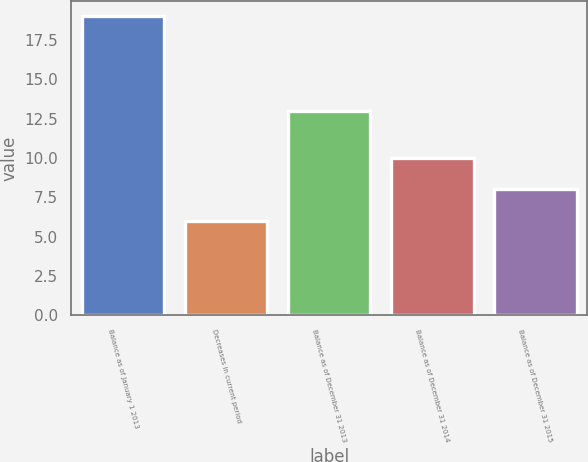<chart> <loc_0><loc_0><loc_500><loc_500><bar_chart><fcel>Balance as of January 1 2013<fcel>Decreases in current period<fcel>Balance as of December 31 2013<fcel>Balance as of December 31 2014<fcel>Balance as of December 31 2015<nl><fcel>19<fcel>6<fcel>13<fcel>10<fcel>8<nl></chart> 